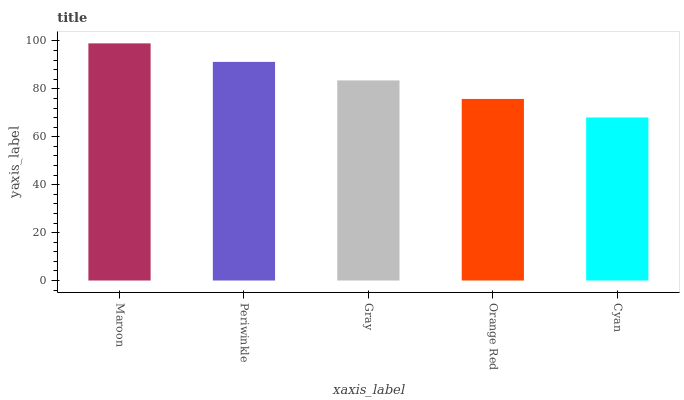Is Cyan the minimum?
Answer yes or no. Yes. Is Maroon the maximum?
Answer yes or no. Yes. Is Periwinkle the minimum?
Answer yes or no. No. Is Periwinkle the maximum?
Answer yes or no. No. Is Maroon greater than Periwinkle?
Answer yes or no. Yes. Is Periwinkle less than Maroon?
Answer yes or no. Yes. Is Periwinkle greater than Maroon?
Answer yes or no. No. Is Maroon less than Periwinkle?
Answer yes or no. No. Is Gray the high median?
Answer yes or no. Yes. Is Gray the low median?
Answer yes or no. Yes. Is Orange Red the high median?
Answer yes or no. No. Is Periwinkle the low median?
Answer yes or no. No. 